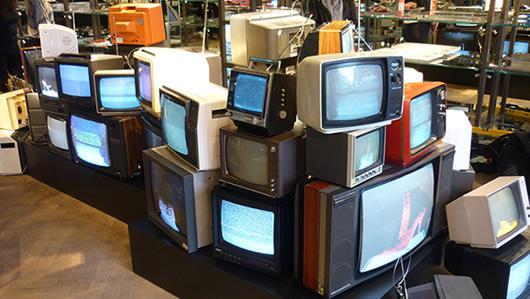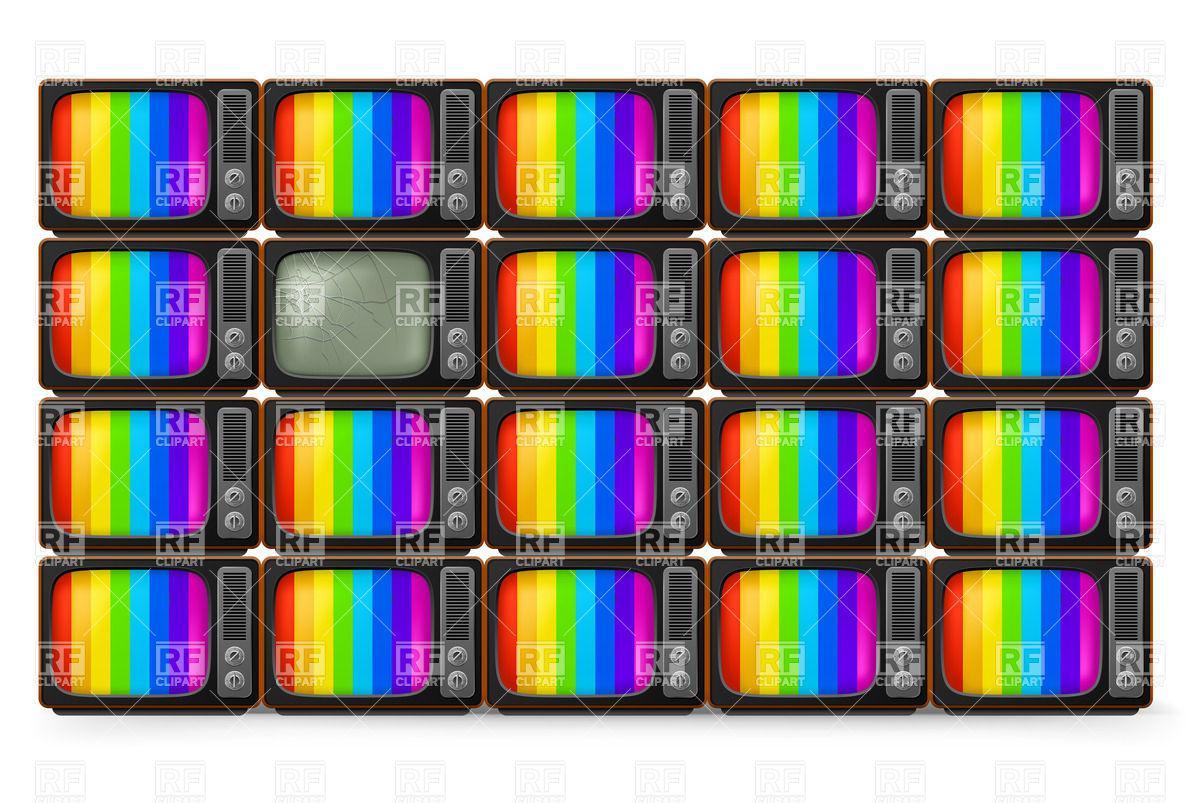The first image is the image on the left, the second image is the image on the right. Given the left and right images, does the statement "There is at least one tv with rainbow stripes on the screen" hold true? Answer yes or no. Yes. The first image is the image on the left, the second image is the image on the right. Examine the images to the left and right. Is the description "The right image shows four stacked rows of same-model TVs, and at least one TV has a gray screen and at least one TV has a rainbow 'test pattern'." accurate? Answer yes or no. Yes. 